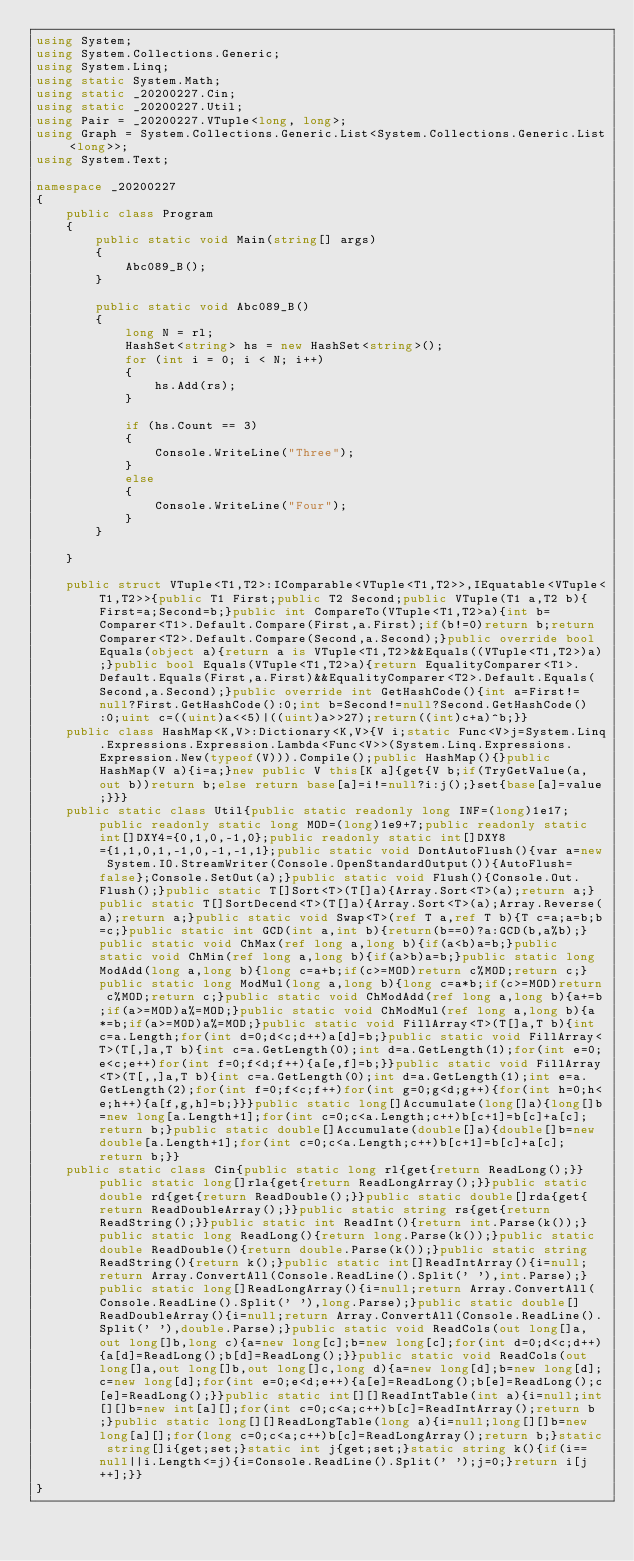<code> <loc_0><loc_0><loc_500><loc_500><_C#_>using System;
using System.Collections.Generic;
using System.Linq;
using static System.Math;
using static _20200227.Cin;
using static _20200227.Util;
using Pair = _20200227.VTuple<long, long>;
using Graph = System.Collections.Generic.List<System.Collections.Generic.List<long>>;
using System.Text;

namespace _20200227
{
    public class Program
    {
        public static void Main(string[] args)
        {
            Abc089_B();
        }

        public static void Abc089_B()
        {
            long N = rl;
            HashSet<string> hs = new HashSet<string>();
            for (int i = 0; i < N; i++)
            {
                hs.Add(rs);
            }

            if (hs.Count == 3)
            {
                Console.WriteLine("Three");
            }
            else
            {
                Console.WriteLine("Four");
            }
        }

    }

    public struct VTuple<T1,T2>:IComparable<VTuple<T1,T2>>,IEquatable<VTuple<T1,T2>>{public T1 First;public T2 Second;public VTuple(T1 a,T2 b){First=a;Second=b;}public int CompareTo(VTuple<T1,T2>a){int b=Comparer<T1>.Default.Compare(First,a.First);if(b!=0)return b;return Comparer<T2>.Default.Compare(Second,a.Second);}public override bool Equals(object a){return a is VTuple<T1,T2>&&Equals((VTuple<T1,T2>)a);}public bool Equals(VTuple<T1,T2>a){return EqualityComparer<T1>.Default.Equals(First,a.First)&&EqualityComparer<T2>.Default.Equals(Second,a.Second);}public override int GetHashCode(){int a=First!=null?First.GetHashCode():0;int b=Second!=null?Second.GetHashCode():0;uint c=((uint)a<<5)|((uint)a>>27);return((int)c+a)^b;}}
    public class HashMap<K,V>:Dictionary<K,V>{V i;static Func<V>j=System.Linq.Expressions.Expression.Lambda<Func<V>>(System.Linq.Expressions.Expression.New(typeof(V))).Compile();public HashMap(){}public HashMap(V a){i=a;}new public V this[K a]{get{V b;if(TryGetValue(a,out b))return b;else return base[a]=i!=null?i:j();}set{base[a]=value;}}}
    public static class Util{public static readonly long INF=(long)1e17;public readonly static long MOD=(long)1e9+7;public readonly static int[]DXY4={0,1,0,-1,0};public readonly static int[]DXY8={1,1,0,1,-1,0,-1,-1,1};public static void DontAutoFlush(){var a=new System.IO.StreamWriter(Console.OpenStandardOutput()){AutoFlush=false};Console.SetOut(a);}public static void Flush(){Console.Out.Flush();}public static T[]Sort<T>(T[]a){Array.Sort<T>(a);return a;}public static T[]SortDecend<T>(T[]a){Array.Sort<T>(a);Array.Reverse(a);return a;}public static void Swap<T>(ref T a,ref T b){T c=a;a=b;b=c;}public static int GCD(int a,int b){return(b==0)?a:GCD(b,a%b);}public static void ChMax(ref long a,long b){if(a<b)a=b;}public static void ChMin(ref long a,long b){if(a>b)a=b;}public static long ModAdd(long a,long b){long c=a+b;if(c>=MOD)return c%MOD;return c;}public static long ModMul(long a,long b){long c=a*b;if(c>=MOD)return c%MOD;return c;}public static void ChModAdd(ref long a,long b){a+=b;if(a>=MOD)a%=MOD;}public static void ChModMul(ref long a,long b){a*=b;if(a>=MOD)a%=MOD;}public static void FillArray<T>(T[]a,T b){int c=a.Length;for(int d=0;d<c;d++)a[d]=b;}public static void FillArray<T>(T[,]a,T b){int c=a.GetLength(0);int d=a.GetLength(1);for(int e=0;e<c;e++)for(int f=0;f<d;f++){a[e,f]=b;}}public static void FillArray<T>(T[,,]a,T b){int c=a.GetLength(0);int d=a.GetLength(1);int e=a.GetLength(2);for(int f=0;f<c;f++)for(int g=0;g<d;g++){for(int h=0;h<e;h++){a[f,g,h]=b;}}}public static long[]Accumulate(long[]a){long[]b=new long[a.Length+1];for(int c=0;c<a.Length;c++)b[c+1]=b[c]+a[c];return b;}public static double[]Accumulate(double[]a){double[]b=new double[a.Length+1];for(int c=0;c<a.Length;c++)b[c+1]=b[c]+a[c];return b;}}
    public static class Cin{public static long rl{get{return ReadLong();}}public static long[]rla{get{return ReadLongArray();}}public static double rd{get{return ReadDouble();}}public static double[]rda{get{return ReadDoubleArray();}}public static string rs{get{return ReadString();}}public static int ReadInt(){return int.Parse(k());}public static long ReadLong(){return long.Parse(k());}public static double ReadDouble(){return double.Parse(k());}public static string ReadString(){return k();}public static int[]ReadIntArray(){i=null;return Array.ConvertAll(Console.ReadLine().Split(' '),int.Parse);}public static long[]ReadLongArray(){i=null;return Array.ConvertAll(Console.ReadLine().Split(' '),long.Parse);}public static double[]ReadDoubleArray(){i=null;return Array.ConvertAll(Console.ReadLine().Split(' '),double.Parse);}public static void ReadCols(out long[]a,out long[]b,long c){a=new long[c];b=new long[c];for(int d=0;d<c;d++){a[d]=ReadLong();b[d]=ReadLong();}}public static void ReadCols(out long[]a,out long[]b,out long[]c,long d){a=new long[d];b=new long[d];c=new long[d];for(int e=0;e<d;e++){a[e]=ReadLong();b[e]=ReadLong();c[e]=ReadLong();}}public static int[][]ReadIntTable(int a){i=null;int[][]b=new int[a][];for(int c=0;c<a;c++)b[c]=ReadIntArray();return b;}public static long[][]ReadLongTable(long a){i=null;long[][]b=new long[a][];for(long c=0;c<a;c++)b[c]=ReadLongArray();return b;}static string[]i{get;set;}static int j{get;set;}static string k(){if(i==null||i.Length<=j){i=Console.ReadLine().Split(' ');j=0;}return i[j++];}}
}
</code> 